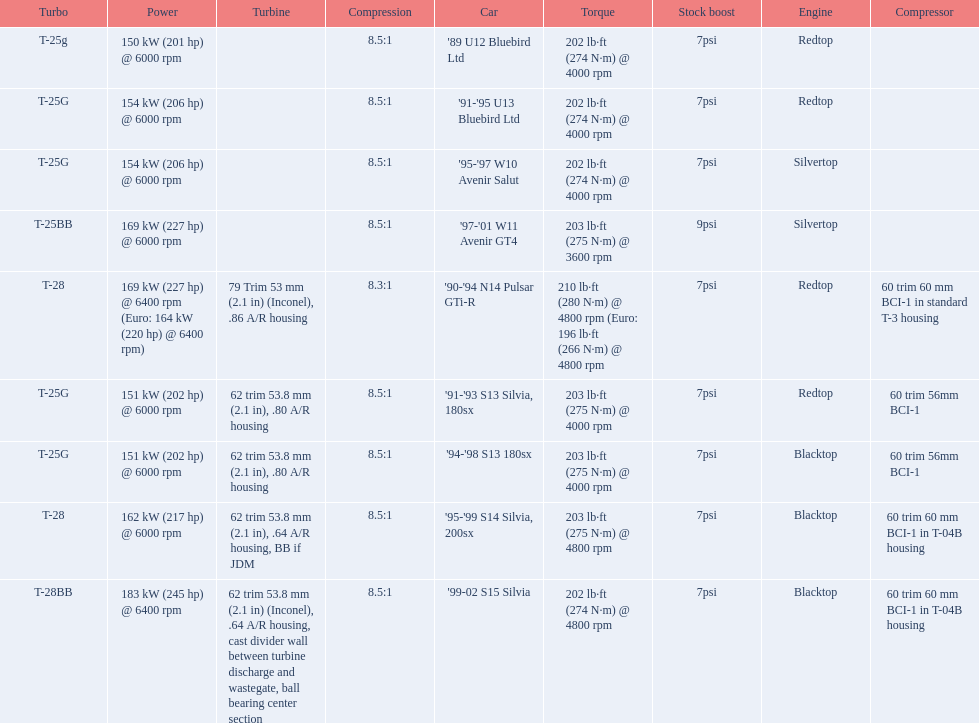Which cars featured blacktop engines? '94-'98 S13 180sx, '95-'99 S14 Silvia, 200sx, '99-02 S15 Silvia. Which of these had t-04b compressor housings? '95-'99 S14 Silvia, 200sx, '99-02 S15 Silvia. Which one of these has the highest horsepower? '99-02 S15 Silvia. 